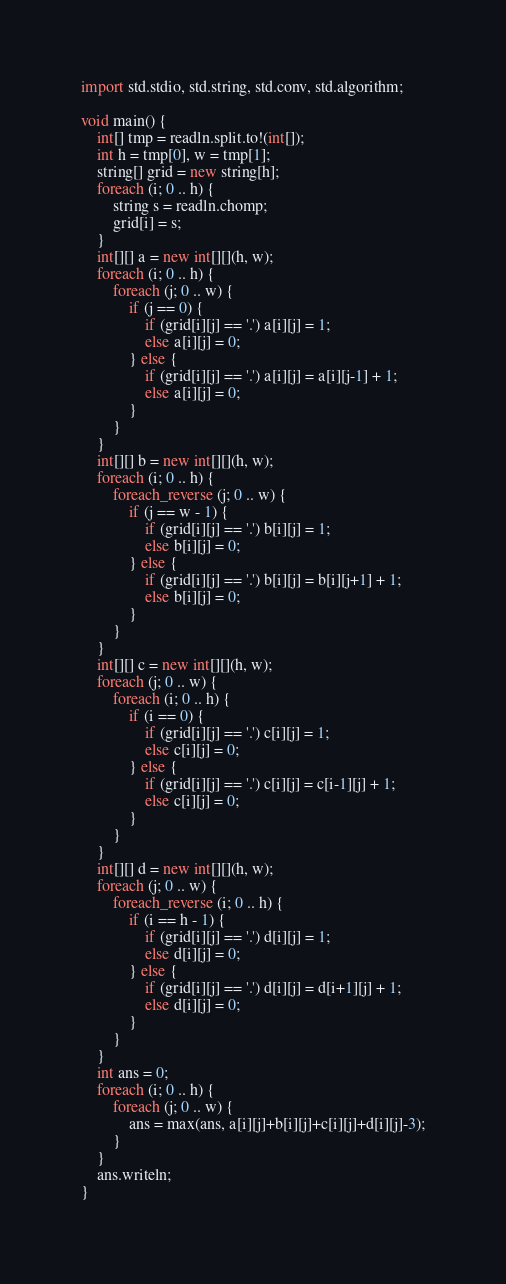Convert code to text. <code><loc_0><loc_0><loc_500><loc_500><_D_>import std.stdio, std.string, std.conv, std.algorithm;

void main() {
    int[] tmp = readln.split.to!(int[]);
    int h = tmp[0], w = tmp[1];
    string[] grid = new string[h];
    foreach (i; 0 .. h) {
        string s = readln.chomp;
        grid[i] = s;
    }
    int[][] a = new int[][](h, w);
    foreach (i; 0 .. h) {
        foreach (j; 0 .. w) {
            if (j == 0) {
                if (grid[i][j] == '.') a[i][j] = 1;
                else a[i][j] = 0;
            } else {
                if (grid[i][j] == '.') a[i][j] = a[i][j-1] + 1;
                else a[i][j] = 0;
            }
        }
    }
    int[][] b = new int[][](h, w);
    foreach (i; 0 .. h) {
        foreach_reverse (j; 0 .. w) {
            if (j == w - 1) {
                if (grid[i][j] == '.') b[i][j] = 1;
                else b[i][j] = 0;
            } else {
                if (grid[i][j] == '.') b[i][j] = b[i][j+1] + 1;
                else b[i][j] = 0;
            }
        }
    }
    int[][] c = new int[][](h, w);
    foreach (j; 0 .. w) {
        foreach (i; 0 .. h) {
            if (i == 0) {
                if (grid[i][j] == '.') c[i][j] = 1;
                else c[i][j] = 0;
            } else {
                if (grid[i][j] == '.') c[i][j] = c[i-1][j] + 1;
                else c[i][j] = 0;
            }
        }
    }
    int[][] d = new int[][](h, w);
    foreach (j; 0 .. w) {
        foreach_reverse (i; 0 .. h) {
            if (i == h - 1) {
                if (grid[i][j] == '.') d[i][j] = 1;
                else d[i][j] = 0;
            } else {
                if (grid[i][j] == '.') d[i][j] = d[i+1][j] + 1;
                else d[i][j] = 0;
            }
        }
    }
    int ans = 0;
    foreach (i; 0 .. h) {
        foreach (j; 0 .. w) {
            ans = max(ans, a[i][j]+b[i][j]+c[i][j]+d[i][j]-3);
        }
    }
    ans.writeln;
}</code> 